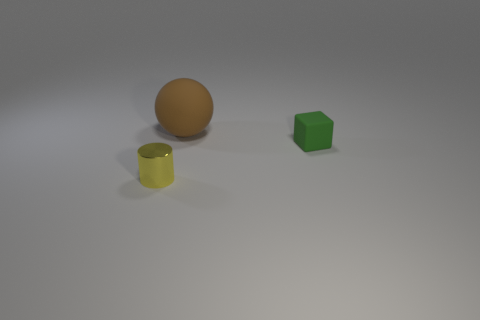Add 1 green objects. How many objects exist? 4 Subtract all cubes. How many objects are left? 2 Subtract all big brown rubber objects. Subtract all large brown rubber spheres. How many objects are left? 1 Add 1 brown spheres. How many brown spheres are left? 2 Add 2 small blocks. How many small blocks exist? 3 Subtract 0 gray spheres. How many objects are left? 3 Subtract 1 spheres. How many spheres are left? 0 Subtract all brown cylinders. Subtract all purple spheres. How many cylinders are left? 1 Subtract all blue cylinders. How many brown blocks are left? 0 